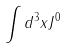<formula> <loc_0><loc_0><loc_500><loc_500>\int d ^ { 3 } x J ^ { 0 }</formula> 